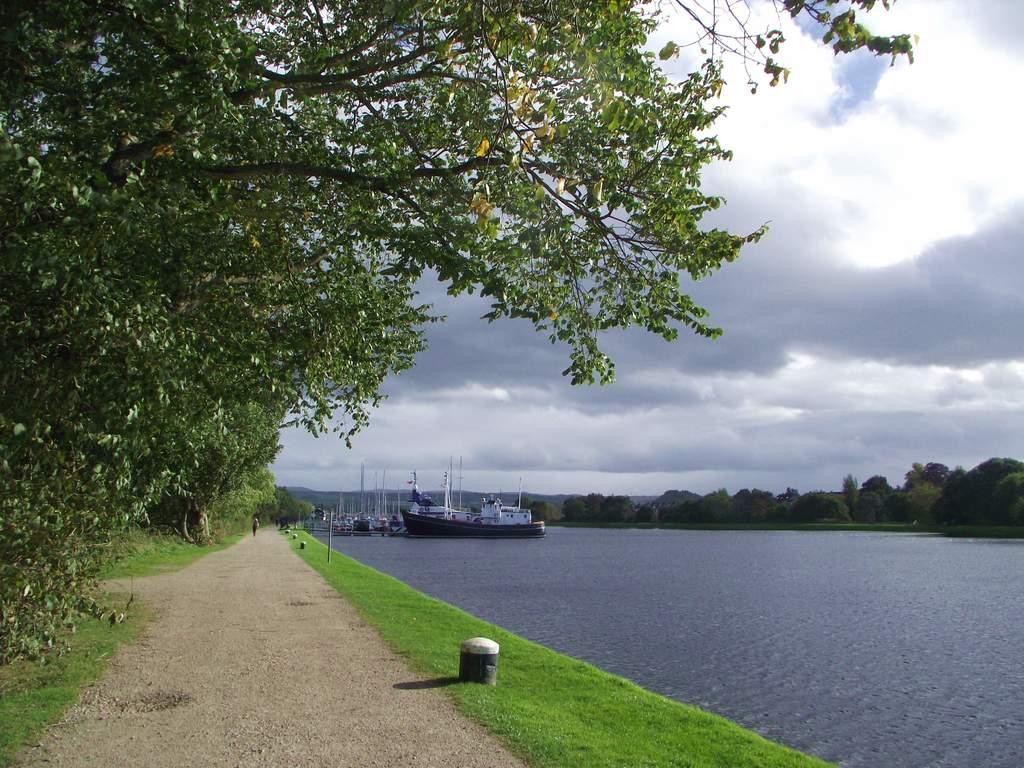Describe this image in one or two sentences. This looks like a pathway. Here is the grass. I think this is a river with the water. I can see the boats on the water. These are the trees. I can see the clouds in the sky. 